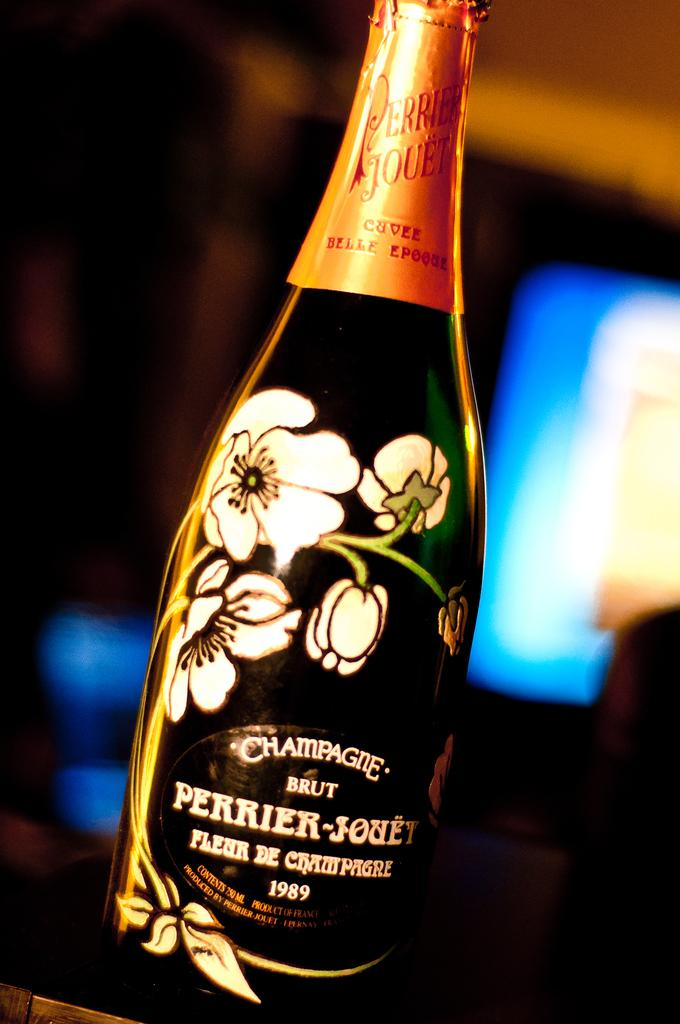Provide a one-sentence caption for the provided image. A bottle of "BRUT PERRIER-JOUET" champagne has flowers on the front. 